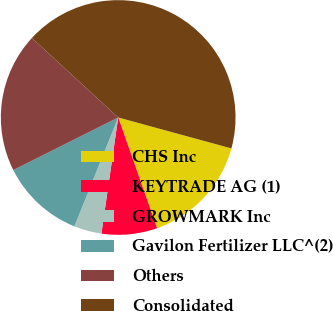Convert chart. <chart><loc_0><loc_0><loc_500><loc_500><pie_chart><fcel>CHS Inc<fcel>KEYTRADE AG (1)<fcel>GROWMARK Inc<fcel>Gavilon Fertilizer LLC^(2)<fcel>Others<fcel>Consolidated<nl><fcel>15.38%<fcel>7.66%<fcel>3.8%<fcel>11.52%<fcel>19.24%<fcel>42.4%<nl></chart> 